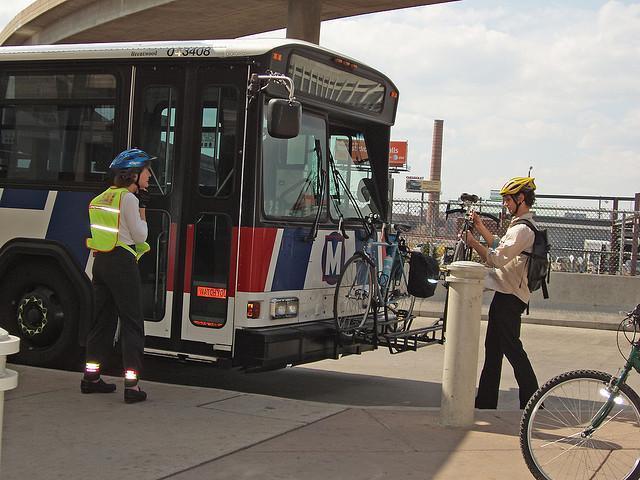How many bicycles are in the picture?
Give a very brief answer. 2. How many people are there?
Give a very brief answer. 2. 